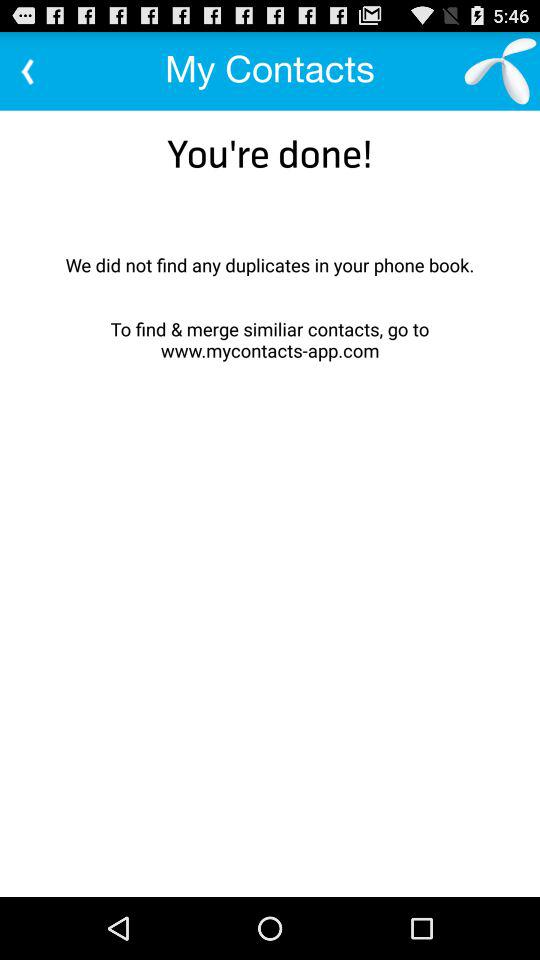What is the application name? The application name is "My Contacts". 